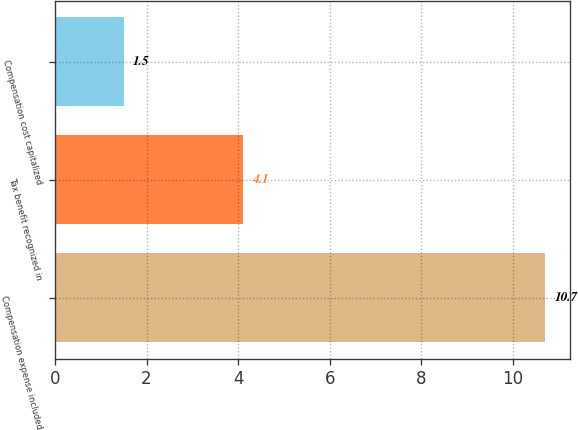Convert chart. <chart><loc_0><loc_0><loc_500><loc_500><bar_chart><fcel>Compensation expense included<fcel>Tax benefit recognized in<fcel>Compensation cost capitalized<nl><fcel>10.7<fcel>4.1<fcel>1.5<nl></chart> 